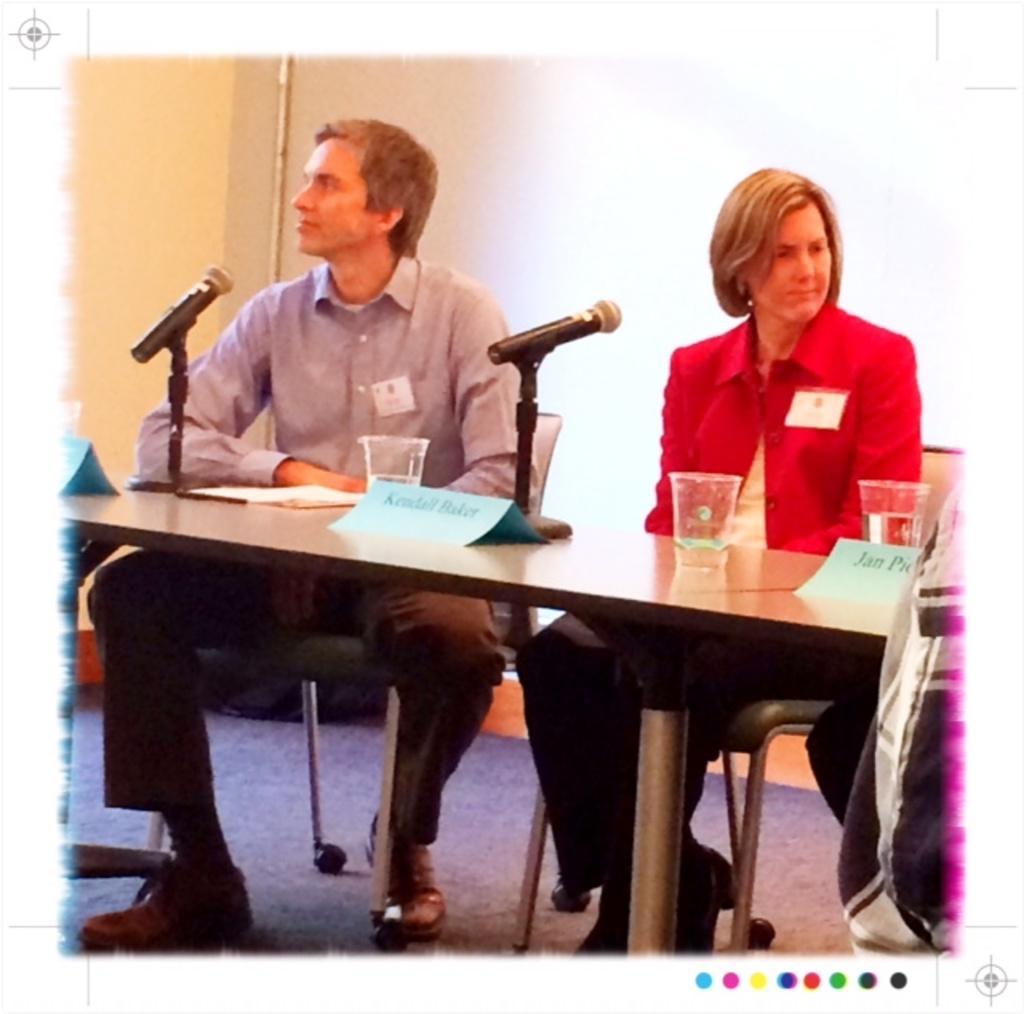Can you describe this image briefly? This picture shows a man and a woman seated on the chairs and speaking with the help of a microphone and we see few glasses on the table. 